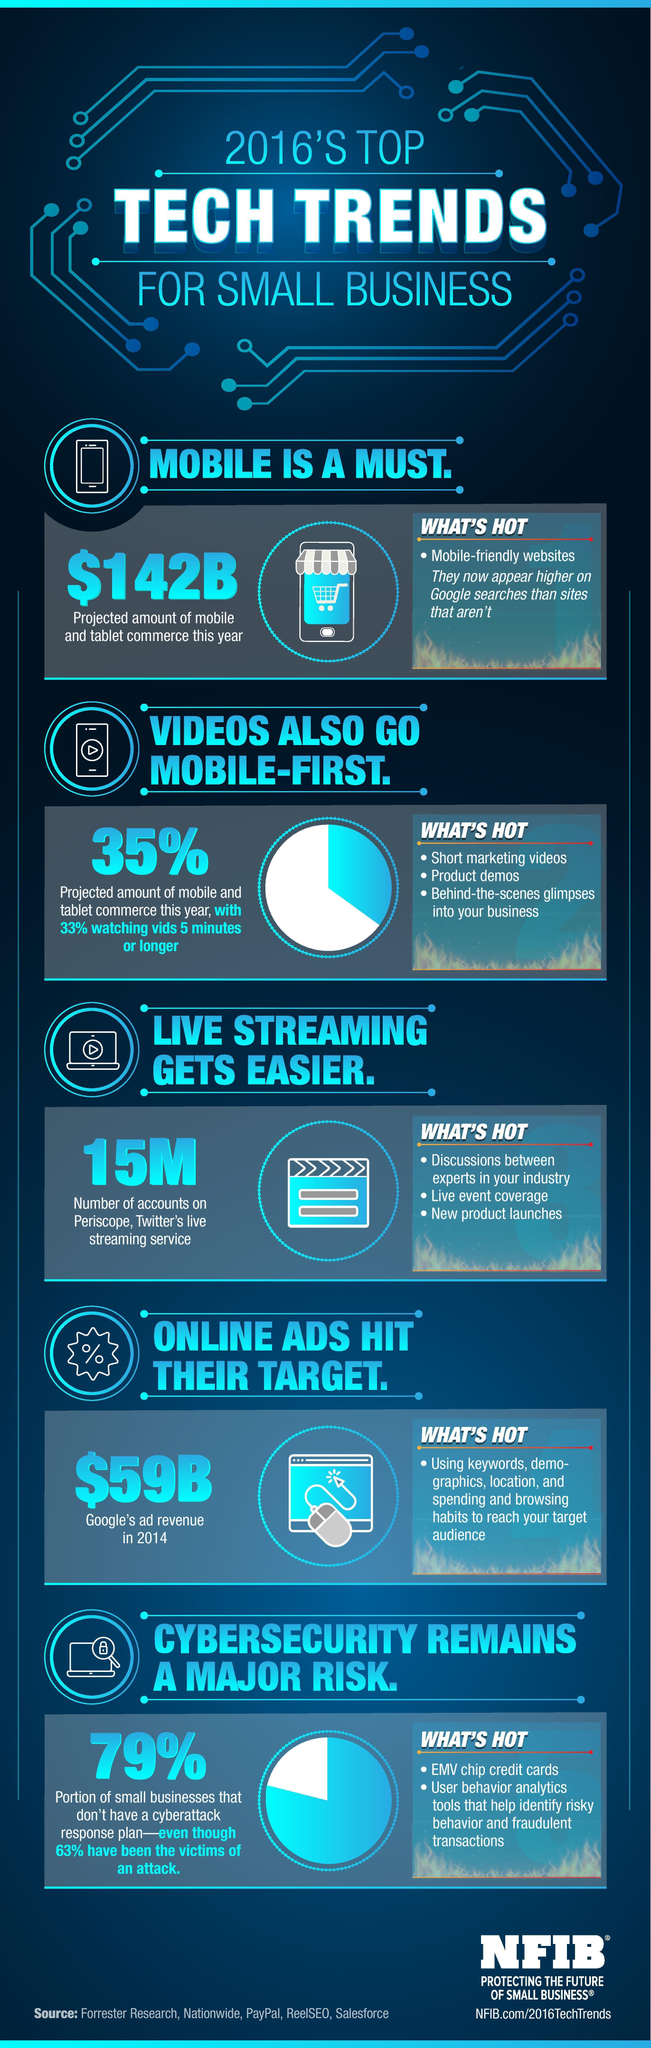what appears higher on google searches
Answer the question with a short phrase. mobile-friendly websites how do you reach your target audience using keywords, demo-graphics, location, and spending and browsing habits what portion of small business dont have a cyberattack response plan 79% what percentage do not watch videos that are 5 minutes or longer 67 